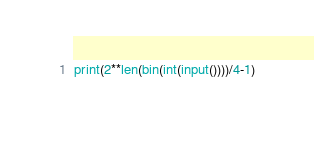Convert code to text. <code><loc_0><loc_0><loc_500><loc_500><_Python_>print(2**len(bin(int(input())))/4-1)</code> 